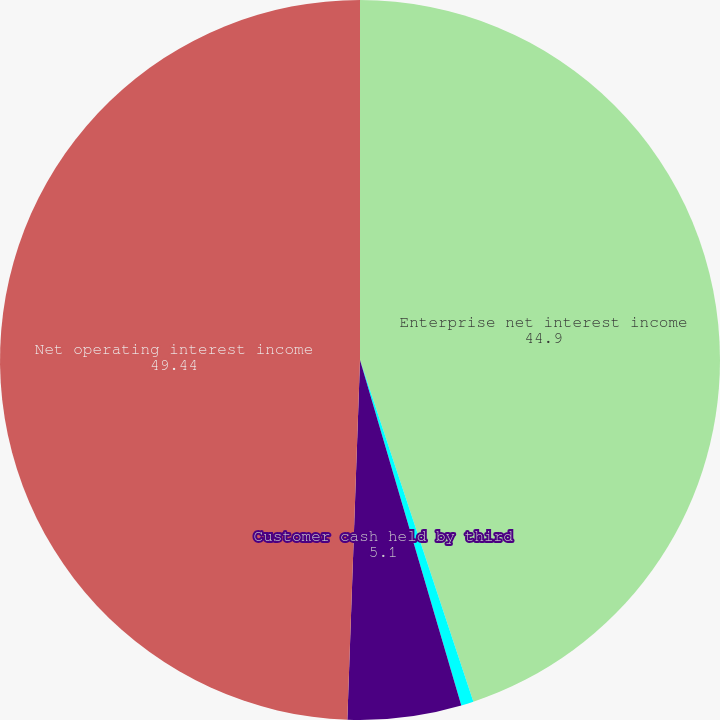Convert chart. <chart><loc_0><loc_0><loc_500><loc_500><pie_chart><fcel>Enterprise net interest income<fcel>Taxable equivalent interest<fcel>Customer cash held by third<fcel>Net operating interest income<nl><fcel>44.9%<fcel>0.56%<fcel>5.1%<fcel>49.44%<nl></chart> 